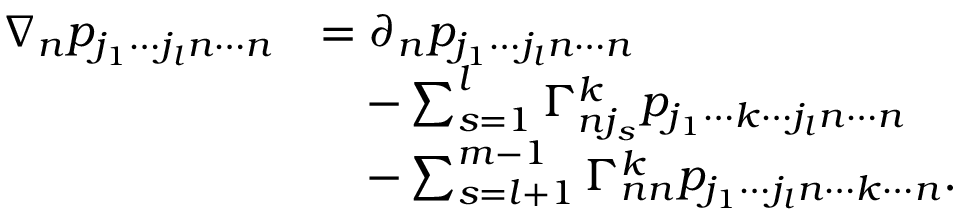<formula> <loc_0><loc_0><loc_500><loc_500>\begin{array} { r l } { \nabla _ { n } p _ { j _ { 1 } \cdots j _ { l } n \cdots n } } & { = \partial _ { n } p _ { j _ { 1 } \cdots j _ { l } n \cdots n } } \\ & { \quad - \sum _ { s = 1 } ^ { l } \Gamma _ { n j _ { s } } ^ { k } p _ { j _ { 1 } \cdots k \cdots j _ { l } n \cdots n } } \\ & { \quad - \sum _ { s = l + 1 } ^ { m - 1 } \Gamma _ { n n } ^ { k } p _ { j _ { 1 } \cdots j _ { l } n \cdots k \cdots n } . } \end{array}</formula> 